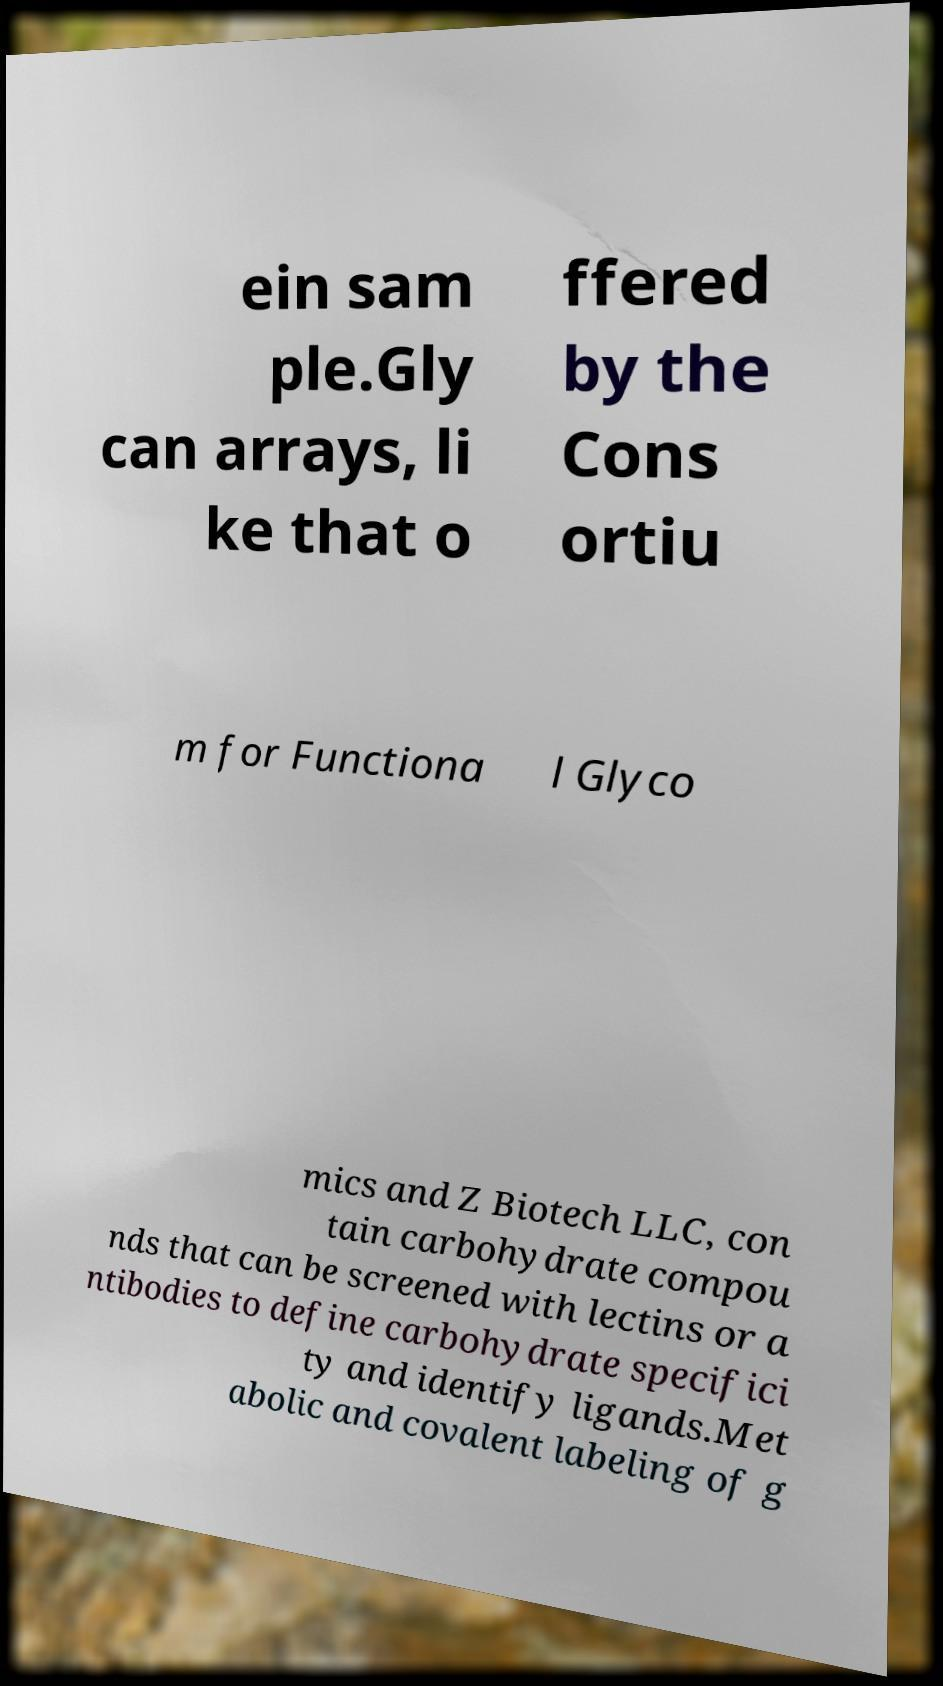Please read and relay the text visible in this image. What does it say? ein sam ple.Gly can arrays, li ke that o ffered by the Cons ortiu m for Functiona l Glyco mics and Z Biotech LLC, con tain carbohydrate compou nds that can be screened with lectins or a ntibodies to define carbohydrate specifici ty and identify ligands.Met abolic and covalent labeling of g 